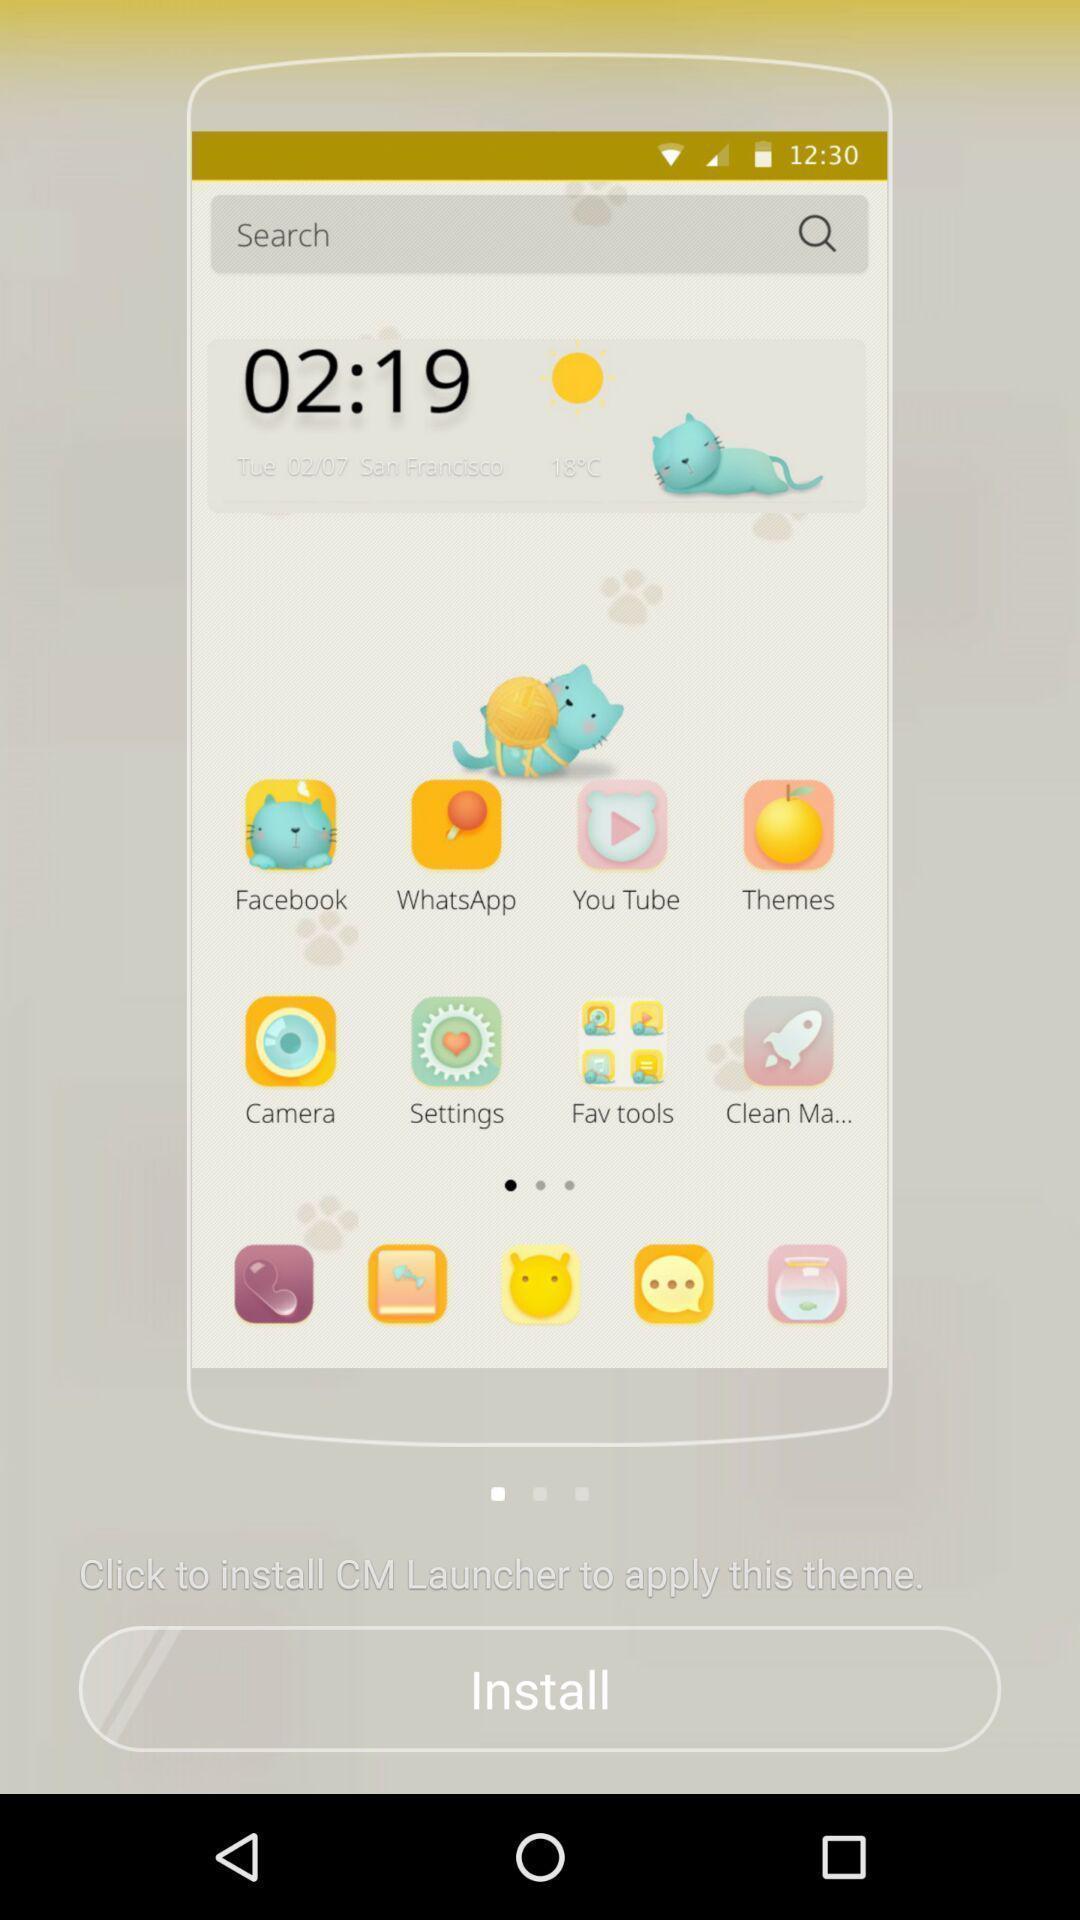Provide a textual representation of this image. Page showing multiple applications on a screen. 